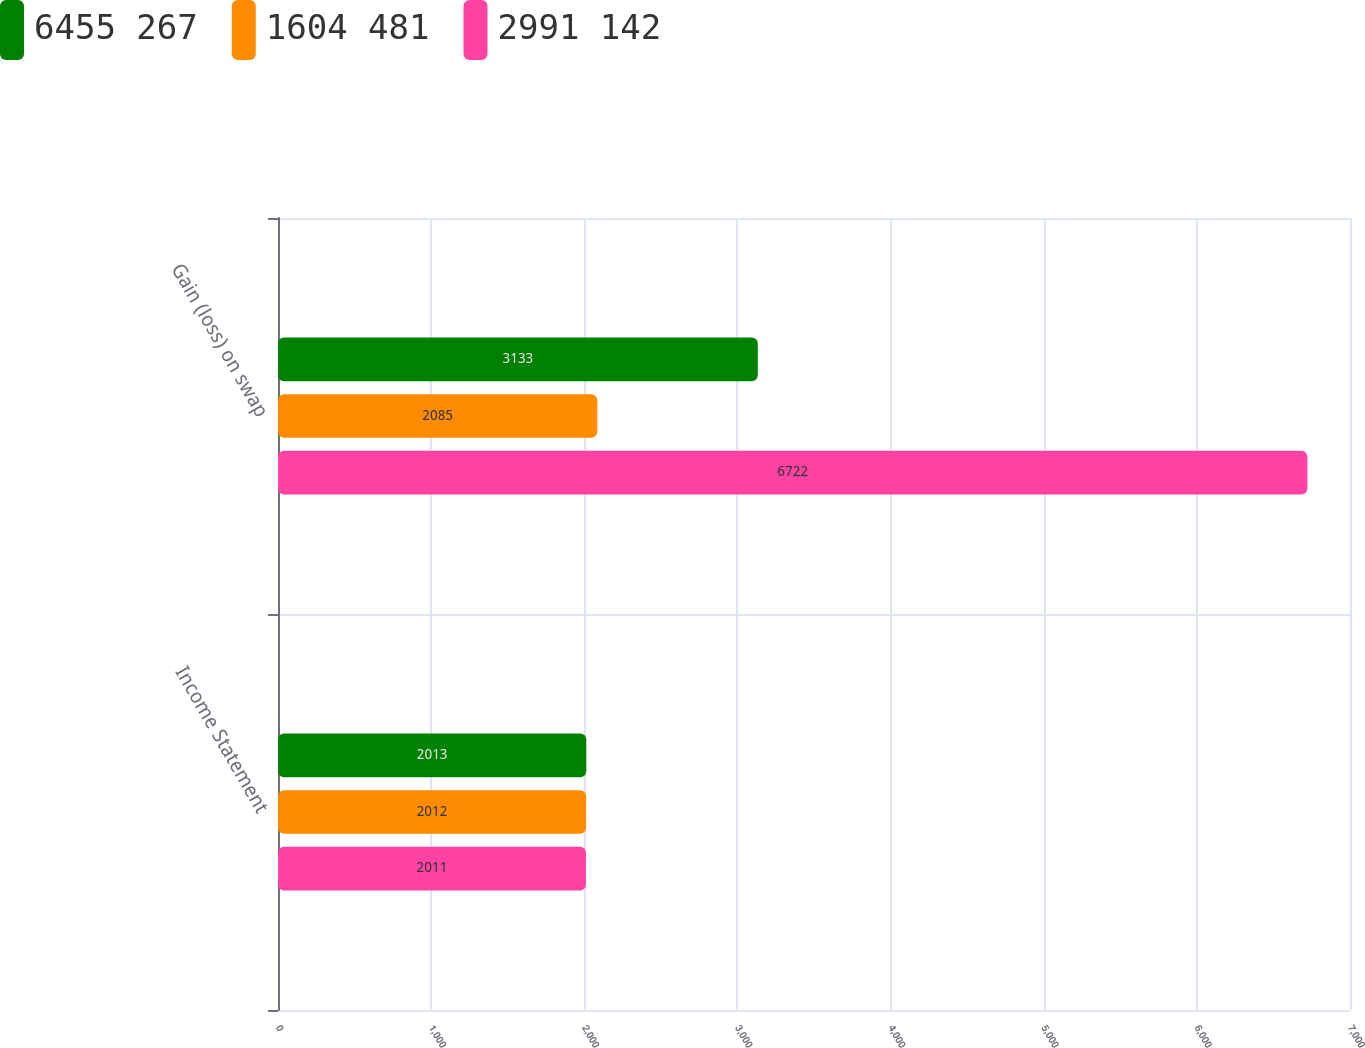<chart> <loc_0><loc_0><loc_500><loc_500><stacked_bar_chart><ecel><fcel>Income Statement<fcel>Gain (loss) on swap<nl><fcel>6455 267<fcel>2013<fcel>3133<nl><fcel>1604 481<fcel>2012<fcel>2085<nl><fcel>2991 142<fcel>2011<fcel>6722<nl></chart> 